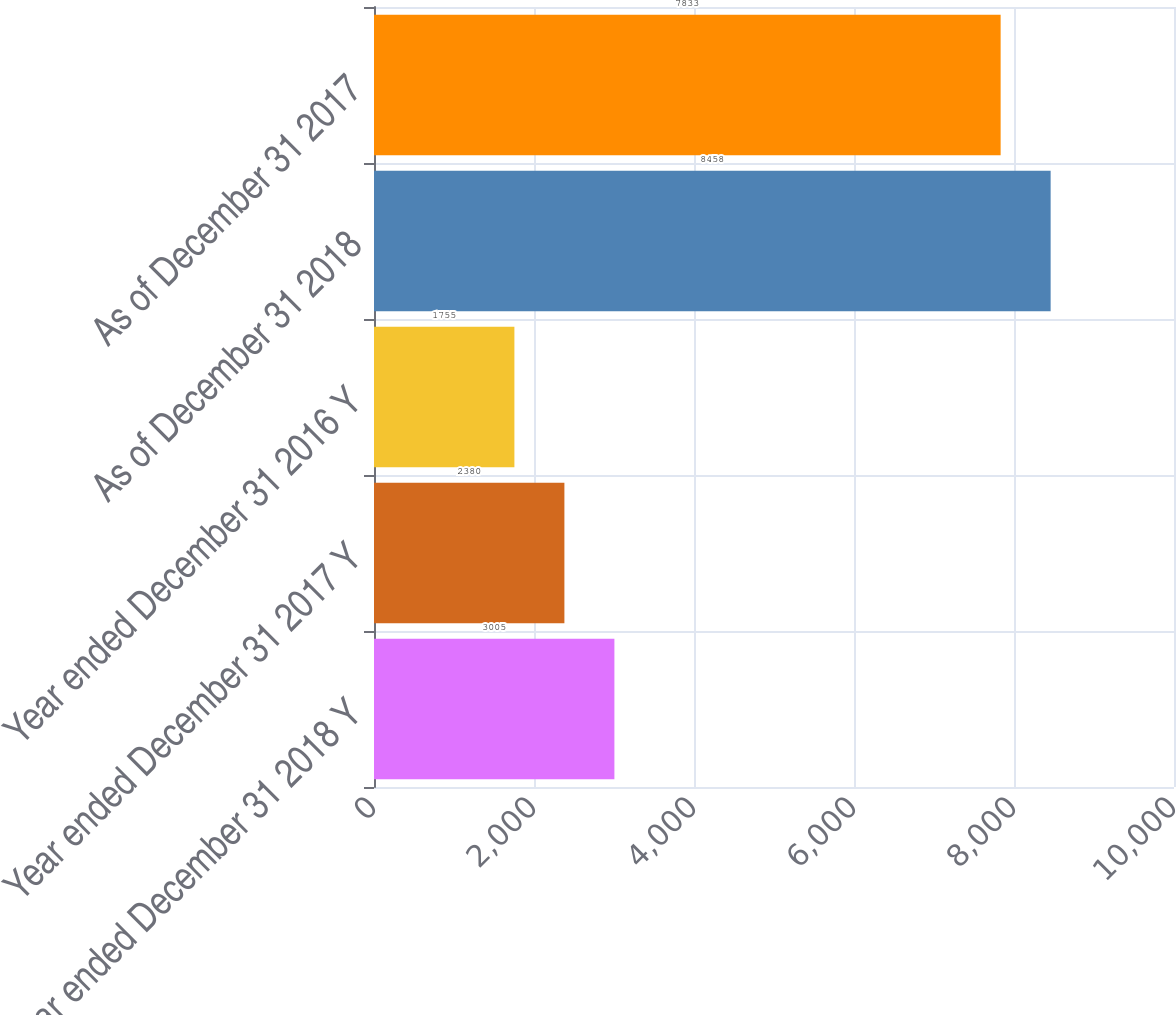<chart> <loc_0><loc_0><loc_500><loc_500><bar_chart><fcel>Year ended December 31 2018 Y<fcel>Year ended December 31 2017 Y<fcel>Year ended December 31 2016 Y<fcel>As of December 31 2018<fcel>As of December 31 2017<nl><fcel>3005<fcel>2380<fcel>1755<fcel>8458<fcel>7833<nl></chart> 